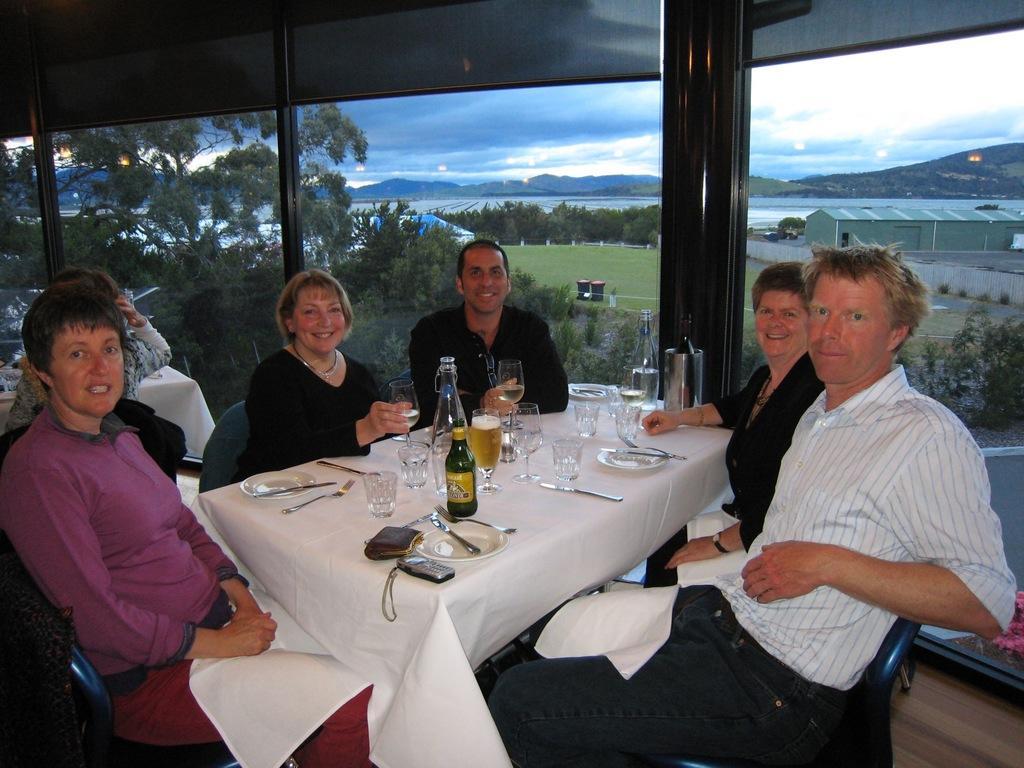In one or two sentences, can you explain what this image depicts? These group of people are sitting around this table, on this table there is a cloth, wallet, mobile, plates, bottles, forks and glasses. From this window we can able to see mountains, trees, grass and a shed. Sky is cloudy. These persons are smiling. 